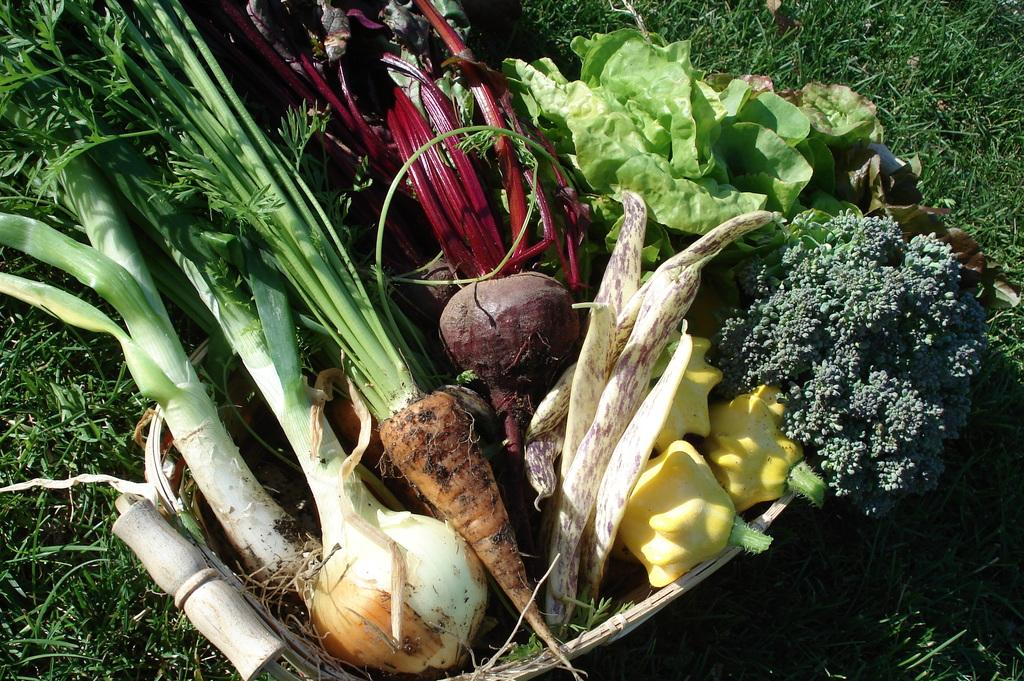What type of food can be seen in the image? There are vegetables in the image. Can you name the specific vegetables that are visible? The vegetables include carrots, beetroot, and leaves. Where are the vegetables located in the image? The vegetables are on the grass. What type of muscle can be seen in the image? There is no muscle present in the image; it features vegetables on the grass. How does the presence of the vegetables affect the surrounding environment? The provided facts do not mention any effect on the surrounding environment, so it cannot be determined from the image. 